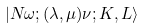<formula> <loc_0><loc_0><loc_500><loc_500>| N \omega ; ( \lambda , \mu ) \nu ; K , L \rangle</formula> 